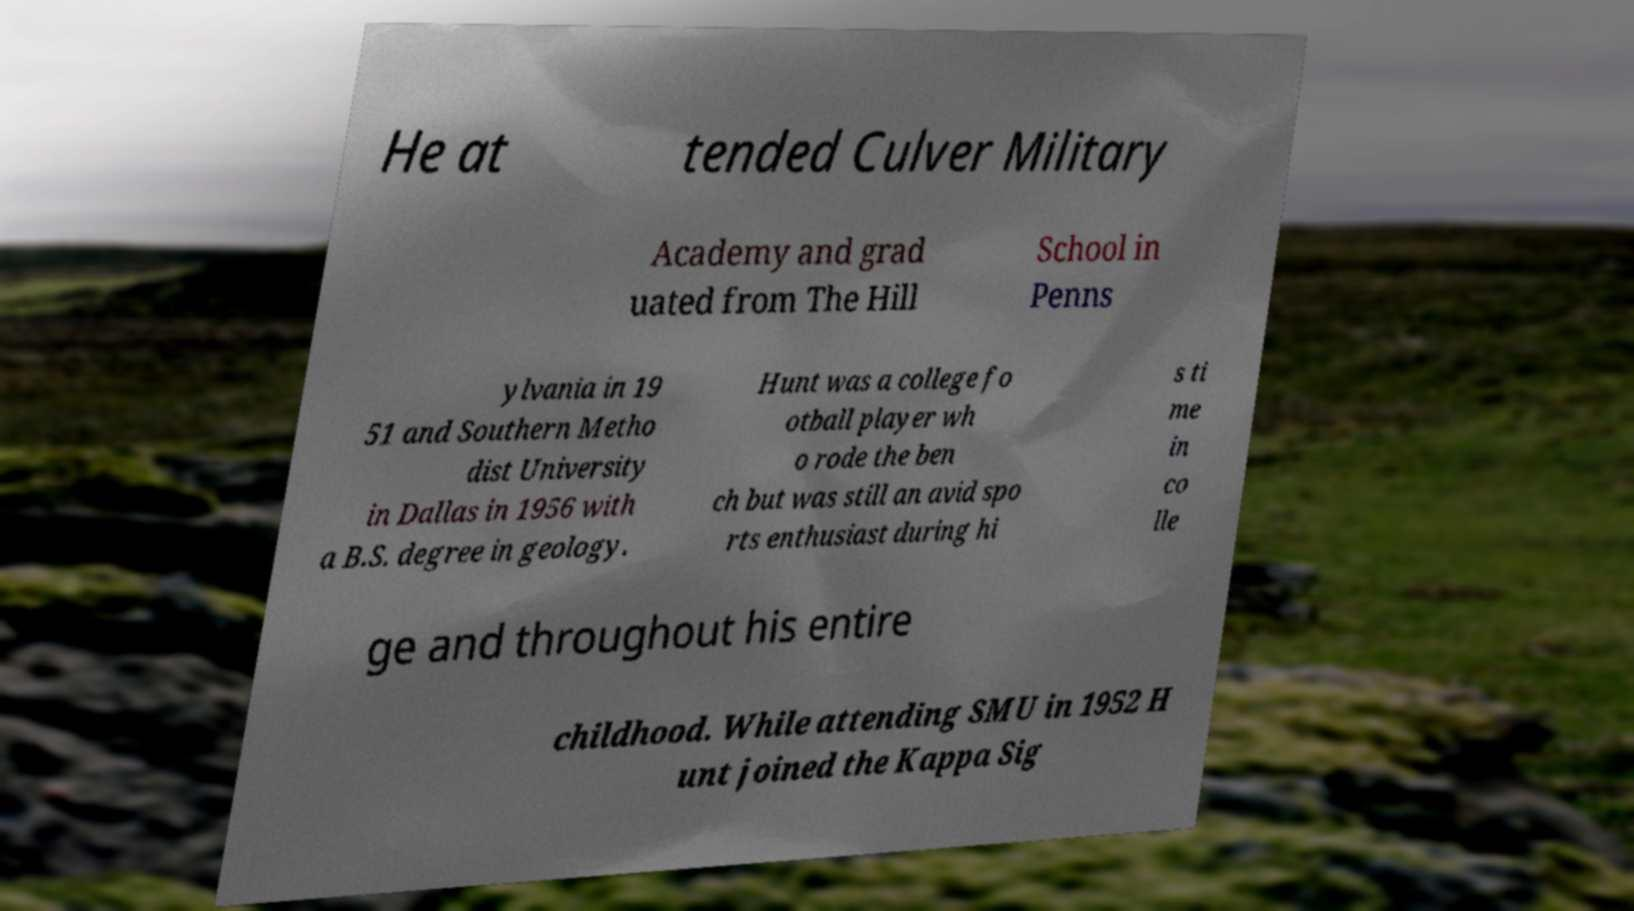I need the written content from this picture converted into text. Can you do that? He at tended Culver Military Academy and grad uated from The Hill School in Penns ylvania in 19 51 and Southern Metho dist University in Dallas in 1956 with a B.S. degree in geology. Hunt was a college fo otball player wh o rode the ben ch but was still an avid spo rts enthusiast during hi s ti me in co lle ge and throughout his entire childhood. While attending SMU in 1952 H unt joined the Kappa Sig 